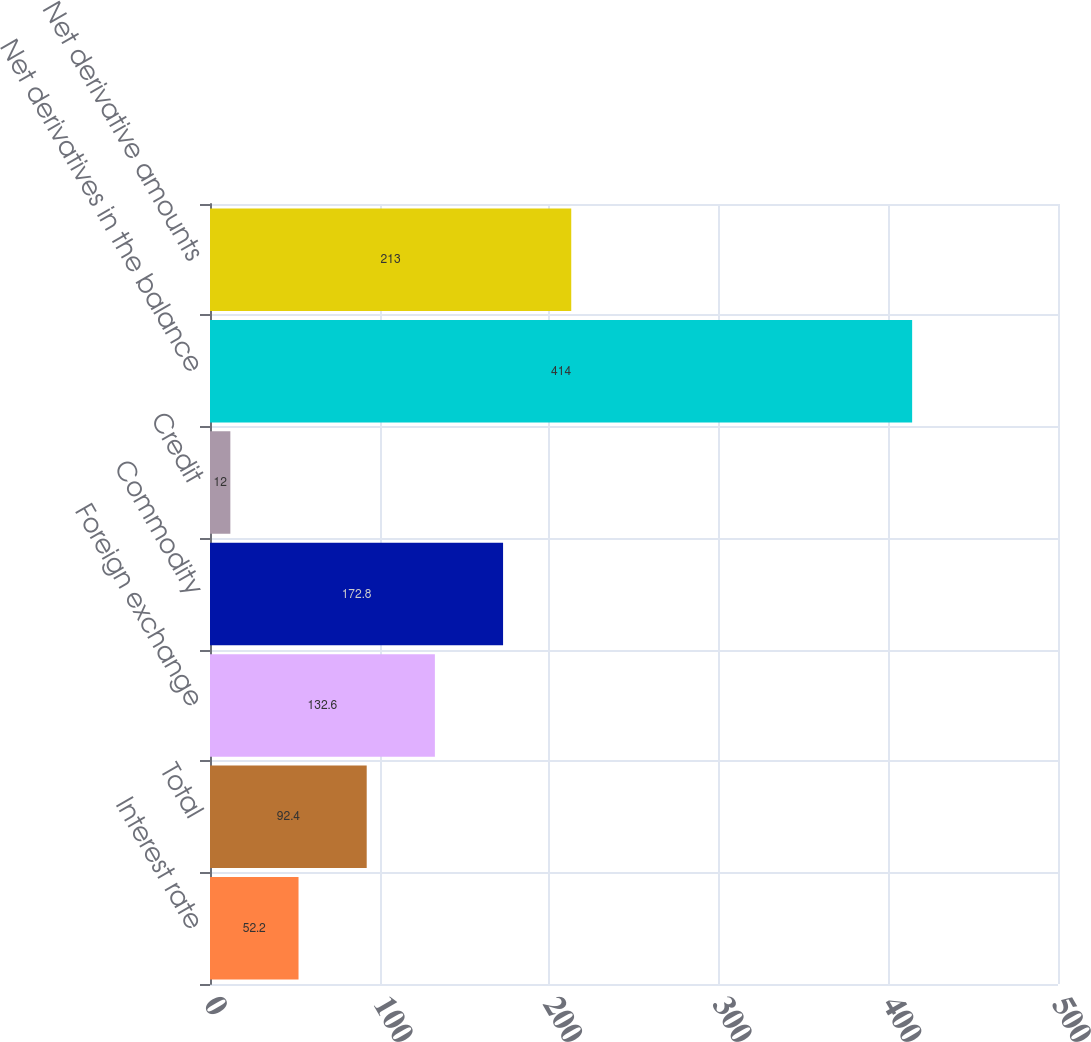Convert chart to OTSL. <chart><loc_0><loc_0><loc_500><loc_500><bar_chart><fcel>Interest rate<fcel>Total<fcel>Foreign exchange<fcel>Commodity<fcel>Credit<fcel>Net derivatives in the balance<fcel>Net derivative amounts<nl><fcel>52.2<fcel>92.4<fcel>132.6<fcel>172.8<fcel>12<fcel>414<fcel>213<nl></chart> 